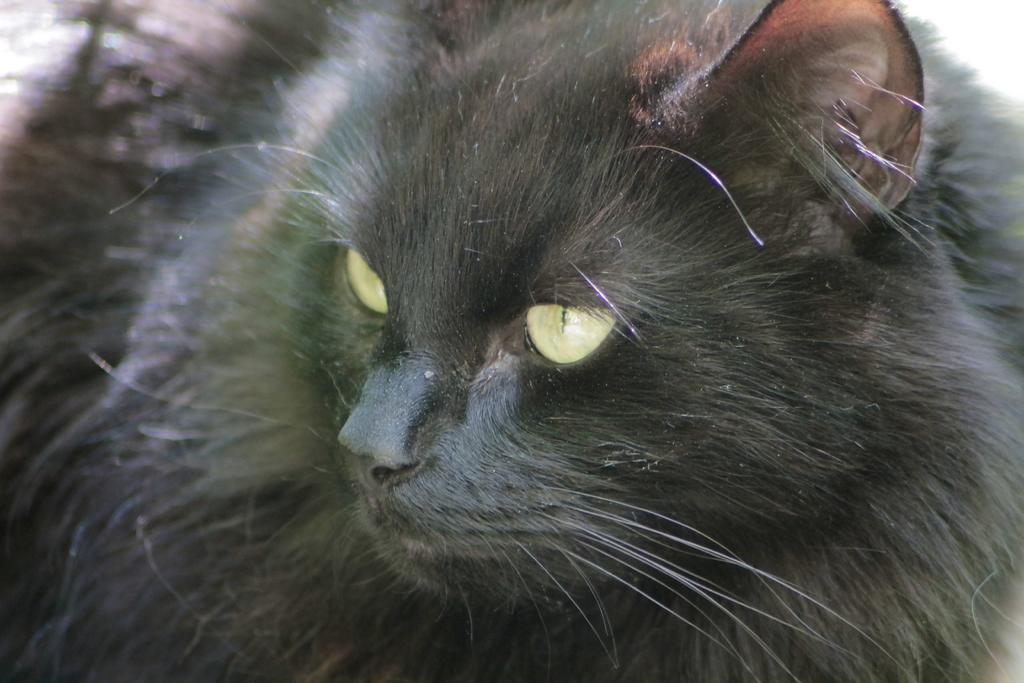What type of animal is in the image? There is a black cat in the image. Can you describe the color of the cat? The cat is black. What type of lettuce is the cat eating in the image? There is no lettuce present in the image, and the cat is not eating anything. 